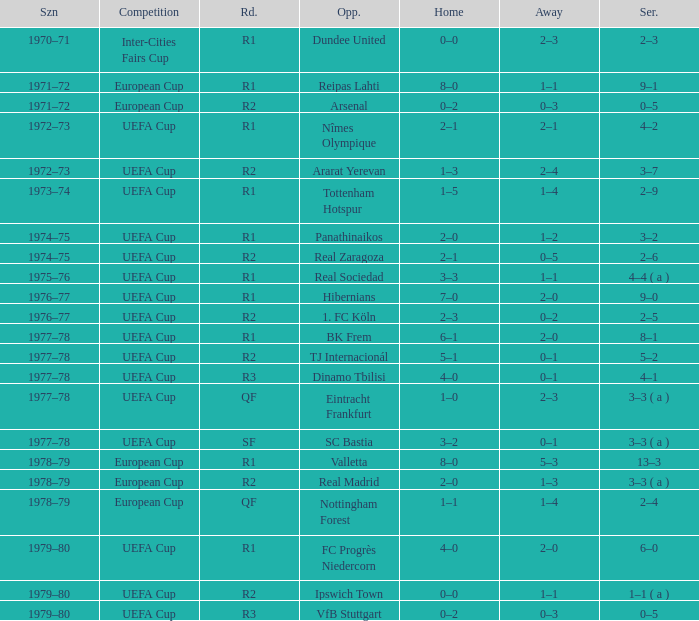Which Season has an Opponent of hibernians? 1976–77. 